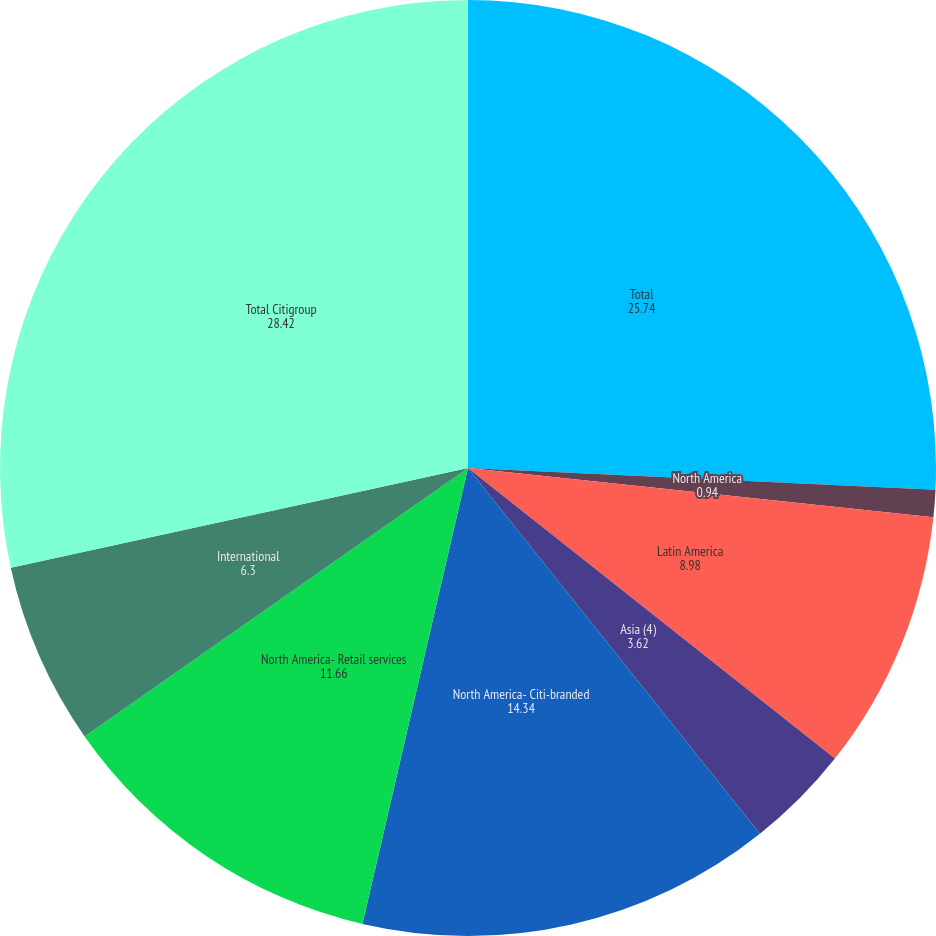Convert chart. <chart><loc_0><loc_0><loc_500><loc_500><pie_chart><fcel>Total<fcel>North America<fcel>Latin America<fcel>Asia (4)<fcel>North America- Citi-branded<fcel>North America- Retail services<fcel>International<fcel>Total Citigroup<nl><fcel>25.74%<fcel>0.94%<fcel>8.98%<fcel>3.62%<fcel>14.34%<fcel>11.66%<fcel>6.3%<fcel>28.42%<nl></chart> 